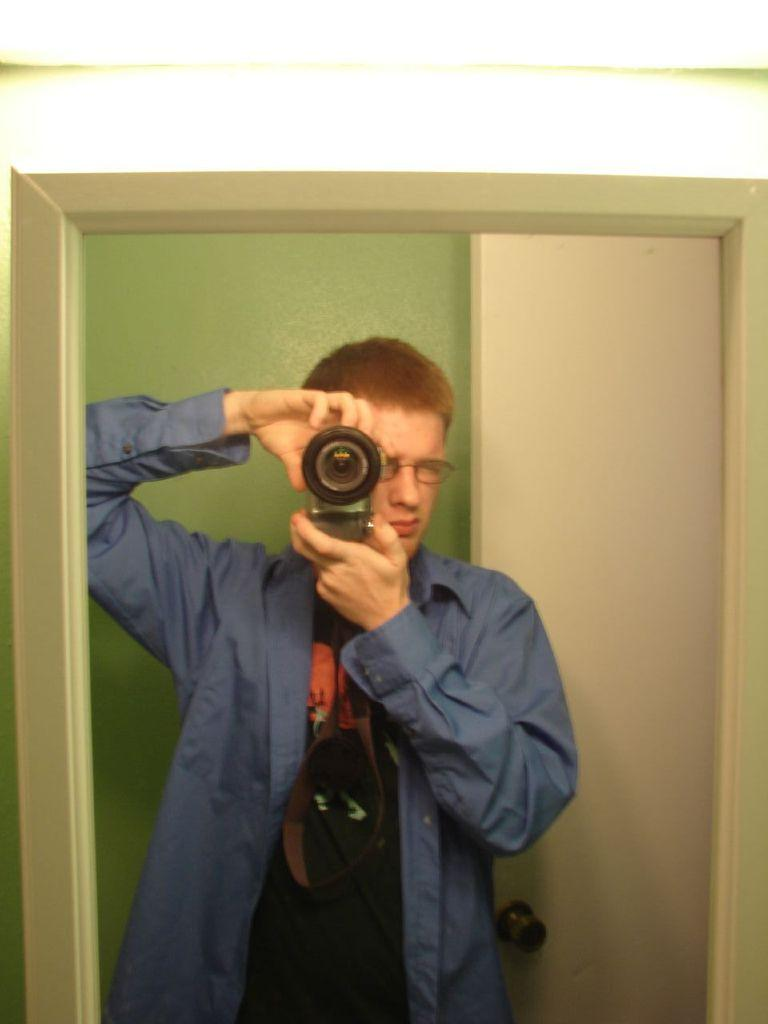Who is present in the image? There is a man in the image. What is the man wearing? The man is wearing spectacles. What is the man holding in the image? The man is holding a camera. What architectural feature can be seen in the image? There is a door in the image. What part of the door is visible in the image? There is a door handle in the image. What can be seen in the background of the image? There is a wall in the background of the image. What type of rhythm can be heard in the image? There is no sound or rhythm present in the image; it is a still photograph. 